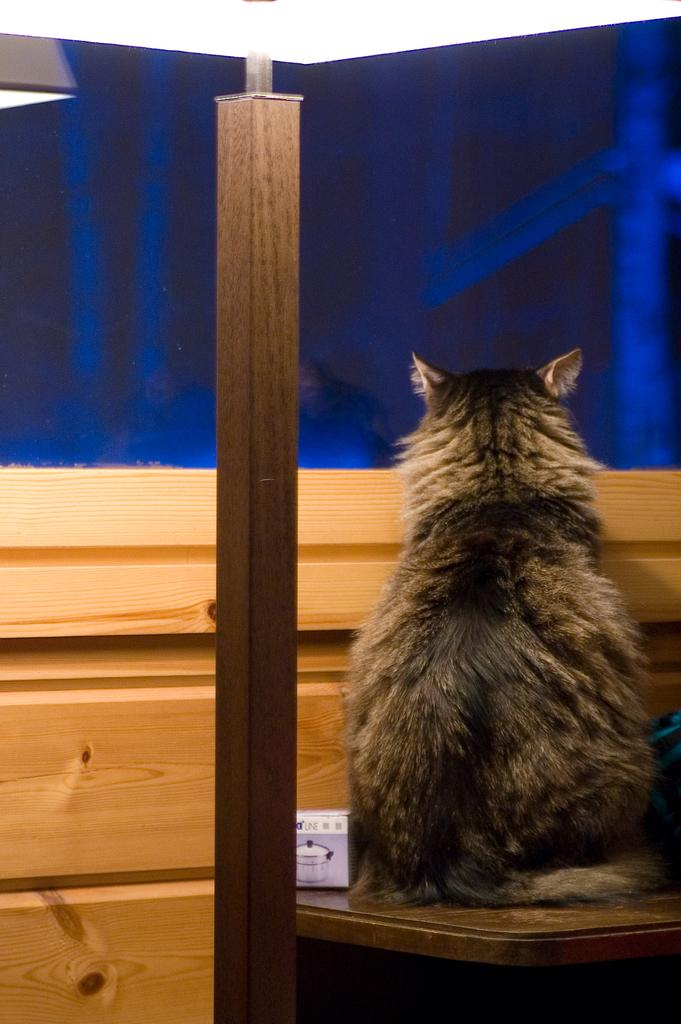What animal is present in the picture? There is a cat in the picture. Where is the cat located in the image? The cat is standing on a table. What can be seen behind the cat? The background of the cat is a curtain. What color is the curtain? The curtain is blue in color. What country is the cat from, as depicted in the image? The image does not provide any information about the cat's country of origin. What type of stone is the cat sitting on in the image? The cat is not sitting on a stone; it is standing on a table. 